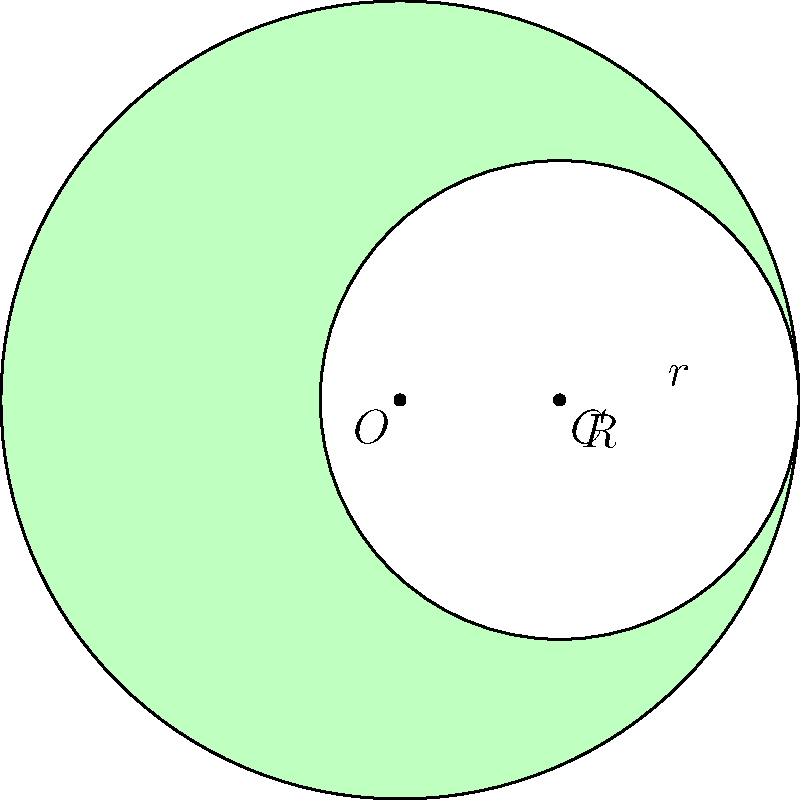Remember the crescent-shaped lawn in front of our old dormitory where we used to study? It was formed by the intersection of two circular areas. If the radius of the larger circle was 50 feet and the radius of the smaller circle was 30 feet, what was the area of the crescent-shaped lawn? Let's approach this step-by-step:

1) The area of the crescent is the difference between the area of the larger circle sector and the area of the smaller circle sector.

2) The area of a circle is given by the formula $A = \pi r^2$.

3) For the larger circle:
   $A_1 = \pi R^2 = \pi (50^2) = 2500\pi$ sq ft

4) For the smaller circle:
   $A_2 = \pi r^2 = \pi (30^2) = 900\pi$ sq ft

5) The area of the crescent is the difference:
   $A_{crescent} = A_1 - A_2 = 2500\pi - 900\pi = 1600\pi$ sq ft

6) To get the numerical value, multiply by $\pi$:
   $A_{crescent} = 1600\pi \approx 5026.55$ sq ft

Therefore, the area of the crescent-shaped lawn was approximately 5026.55 square feet.
Answer: $1600\pi$ sq ft (or approximately 5026.55 sq ft) 